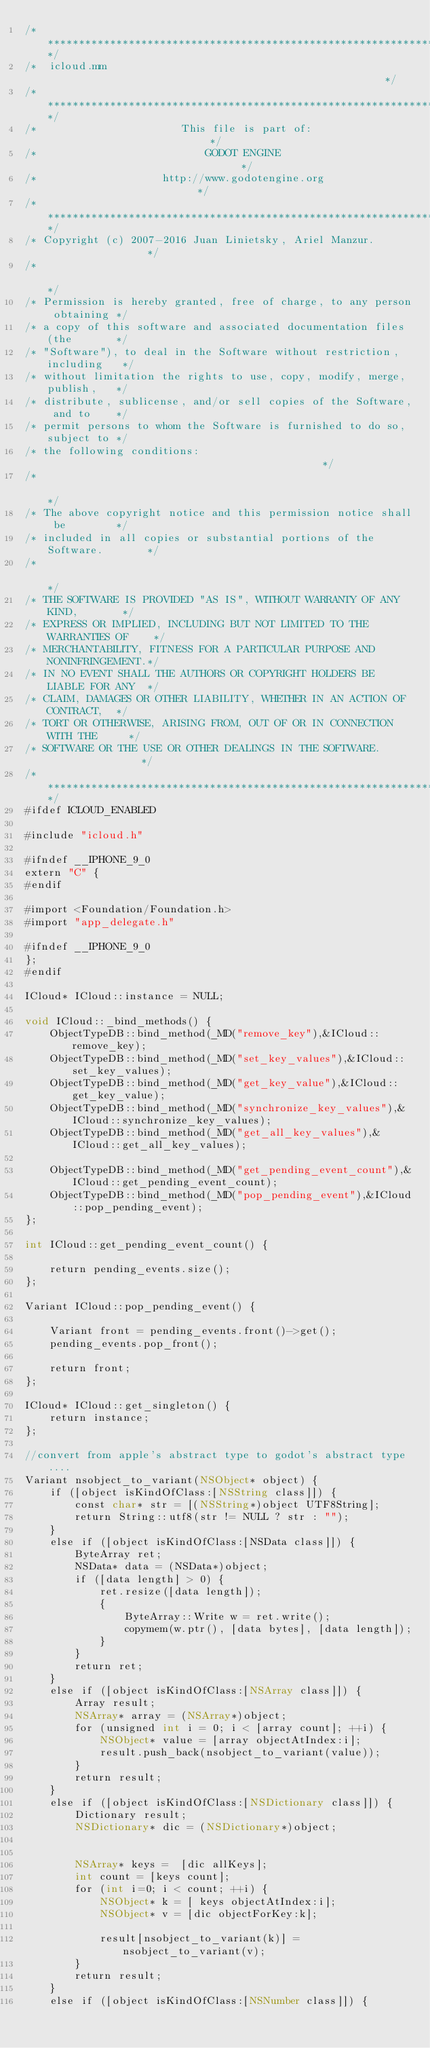Convert code to text. <code><loc_0><loc_0><loc_500><loc_500><_ObjectiveC_>/*************************************************************************/
/*  icloud.mm                                                       */
/*************************************************************************/
/*                       This file is part of:                           */
/*                           GODOT ENGINE                                */
/*                    http://www.godotengine.org                         */
/*************************************************************************/
/* Copyright (c) 2007-2016 Juan Linietsky, Ariel Manzur.                 */
/*                                                                       */
/* Permission is hereby granted, free of charge, to any person obtaining */
/* a copy of this software and associated documentation files (the       */
/* "Software"), to deal in the Software without restriction, including   */
/* without limitation the rights to use, copy, modify, merge, publish,   */
/* distribute, sublicense, and/or sell copies of the Software, and to    */
/* permit persons to whom the Software is furnished to do so, subject to */
/* the following conditions:                                             */
/*                                                                       */
/* The above copyright notice and this permission notice shall be        */
/* included in all copies or substantial portions of the Software.       */
/*                                                                       */
/* THE SOFTWARE IS PROVIDED "AS IS", WITHOUT WARRANTY OF ANY KIND,       */
/* EXPRESS OR IMPLIED, INCLUDING BUT NOT LIMITED TO THE WARRANTIES OF    */
/* MERCHANTABILITY, FITNESS FOR A PARTICULAR PURPOSE AND NONINFRINGEMENT.*/
/* IN NO EVENT SHALL THE AUTHORS OR COPYRIGHT HOLDERS BE LIABLE FOR ANY  */
/* CLAIM, DAMAGES OR OTHER LIABILITY, WHETHER IN AN ACTION OF CONTRACT,  */
/* TORT OR OTHERWISE, ARISING FROM, OUT OF OR IN CONNECTION WITH THE     */
/* SOFTWARE OR THE USE OR OTHER DEALINGS IN THE SOFTWARE.                */
/*************************************************************************/
#ifdef ICLOUD_ENABLED

#include "icloud.h"

#ifndef __IPHONE_9_0
extern "C" {
#endif

#import <Foundation/Foundation.h>
#import "app_delegate.h"

#ifndef __IPHONE_9_0
};
#endif

ICloud* ICloud::instance = NULL;

void ICloud::_bind_methods() {
	ObjectTypeDB::bind_method(_MD("remove_key"),&ICloud::remove_key);
	ObjectTypeDB::bind_method(_MD("set_key_values"),&ICloud::set_key_values);
	ObjectTypeDB::bind_method(_MD("get_key_value"),&ICloud::get_key_value);
	ObjectTypeDB::bind_method(_MD("synchronize_key_values"),&ICloud::synchronize_key_values);
	ObjectTypeDB::bind_method(_MD("get_all_key_values"),&ICloud::get_all_key_values);
	
	ObjectTypeDB::bind_method(_MD("get_pending_event_count"),&ICloud::get_pending_event_count);
	ObjectTypeDB::bind_method(_MD("pop_pending_event"),&ICloud::pop_pending_event);
};

int ICloud::get_pending_event_count() {

	return pending_events.size();
};

Variant ICloud::pop_pending_event() {

	Variant front = pending_events.front()->get();
	pending_events.pop_front();

	return front;
};

ICloud* ICloud::get_singleton() {
	return instance;
};

//convert from apple's abstract type to godot's abstract type....
Variant nsobject_to_variant(NSObject* object) {
	if ([object isKindOfClass:[NSString class]]) {
		const char* str = [(NSString*)object UTF8String];
		return String::utf8(str != NULL ? str : "");
	}
	else if ([object isKindOfClass:[NSData class]]) {
		ByteArray ret;
		NSData* data = (NSData*)object;
		if ([data length] > 0) {
			ret.resize([data length]);
			{
				ByteArray::Write w = ret.write();			
				copymem(w.ptr(), [data bytes], [data length]);
			}
		}
		return ret;
	}
	else if ([object isKindOfClass:[NSArray class]]) {
		Array result;
		NSArray* array = (NSArray*)object;
		for (unsigned int i = 0; i < [array count]; ++i) {
			NSObject* value = [array objectAtIndex:i];
			result.push_back(nsobject_to_variant(value));
		}
		return result;
	}
	else if ([object isKindOfClass:[NSDictionary class]]) {
		Dictionary result;
		NSDictionary* dic = (NSDictionary*)object;
		
		
		NSArray* keys =  [dic allKeys];
		int count = [keys count];
		for (int i=0; i < count; ++i) {
			NSObject* k = [ keys objectAtIndex:i];
			NSObject* v = [dic objectForKey:k];
			
			result[nsobject_to_variant(k)] = nsobject_to_variant(v);
		}
		return result;
	}
	else if ([object isKindOfClass:[NSNumber class]]) {</code> 